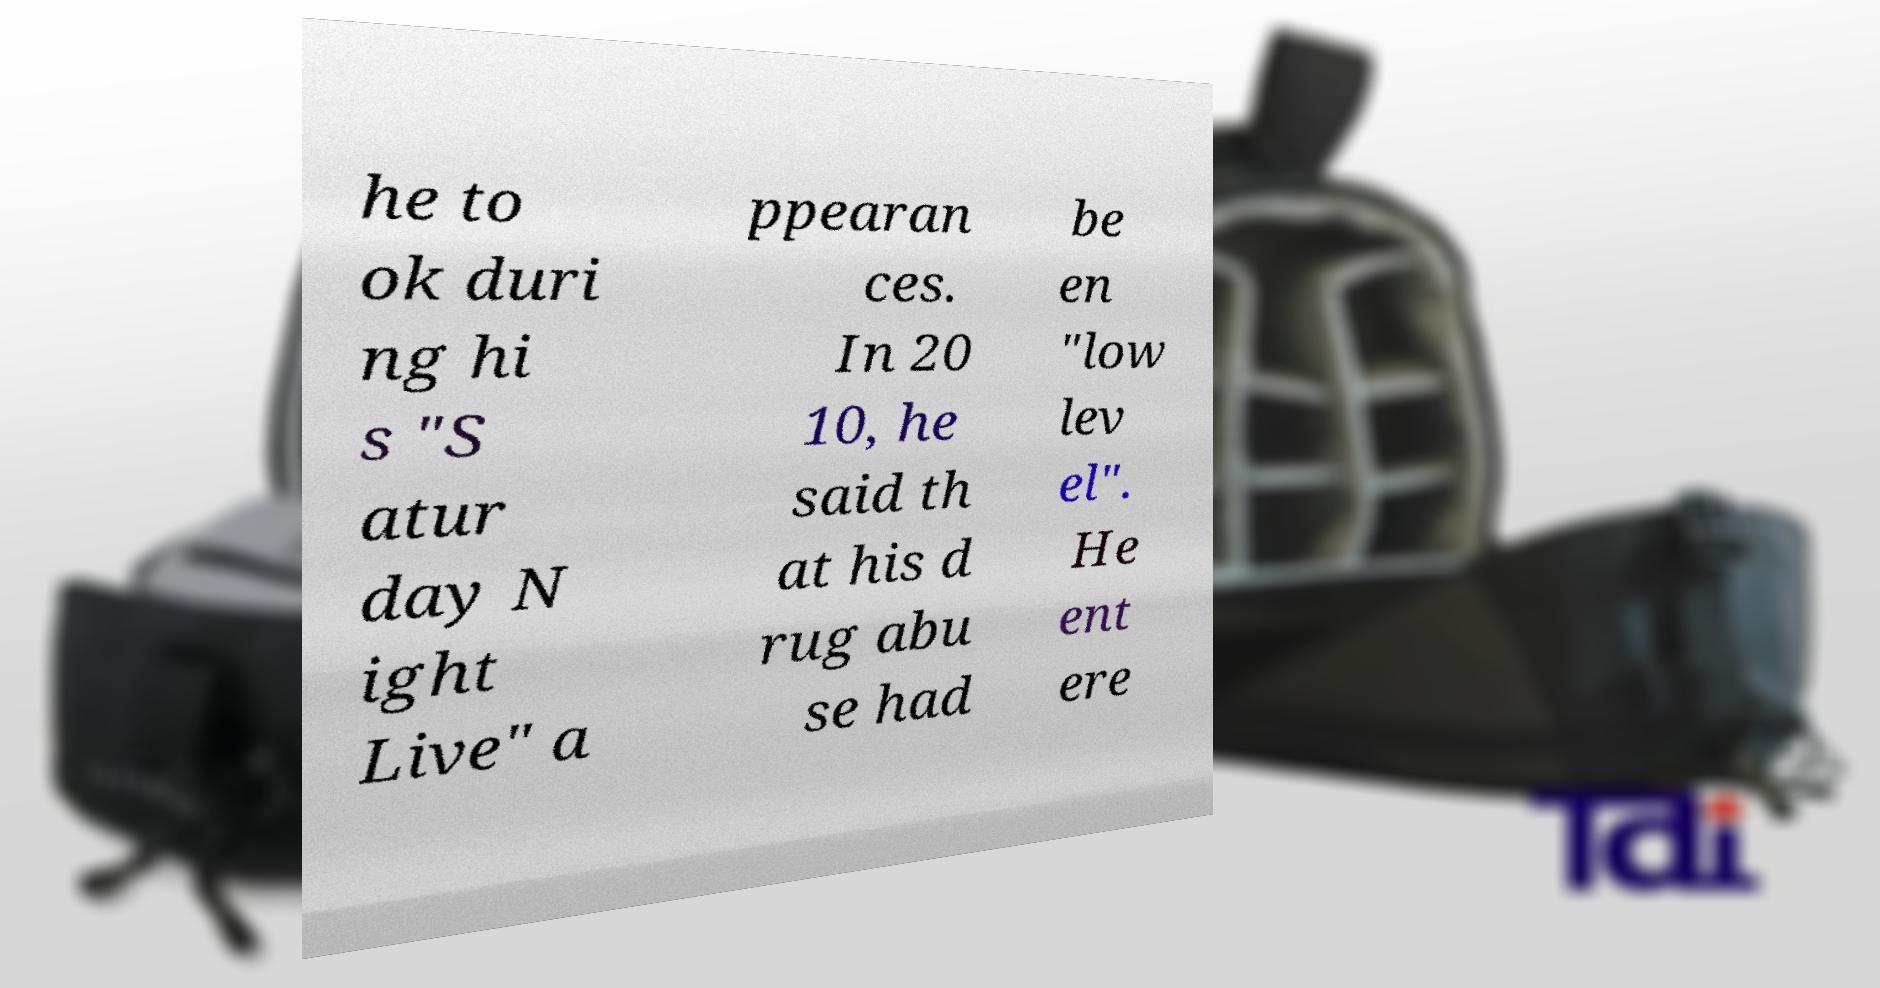Please identify and transcribe the text found in this image. he to ok duri ng hi s "S atur day N ight Live" a ppearan ces. In 20 10, he said th at his d rug abu se had be en "low lev el". He ent ere 